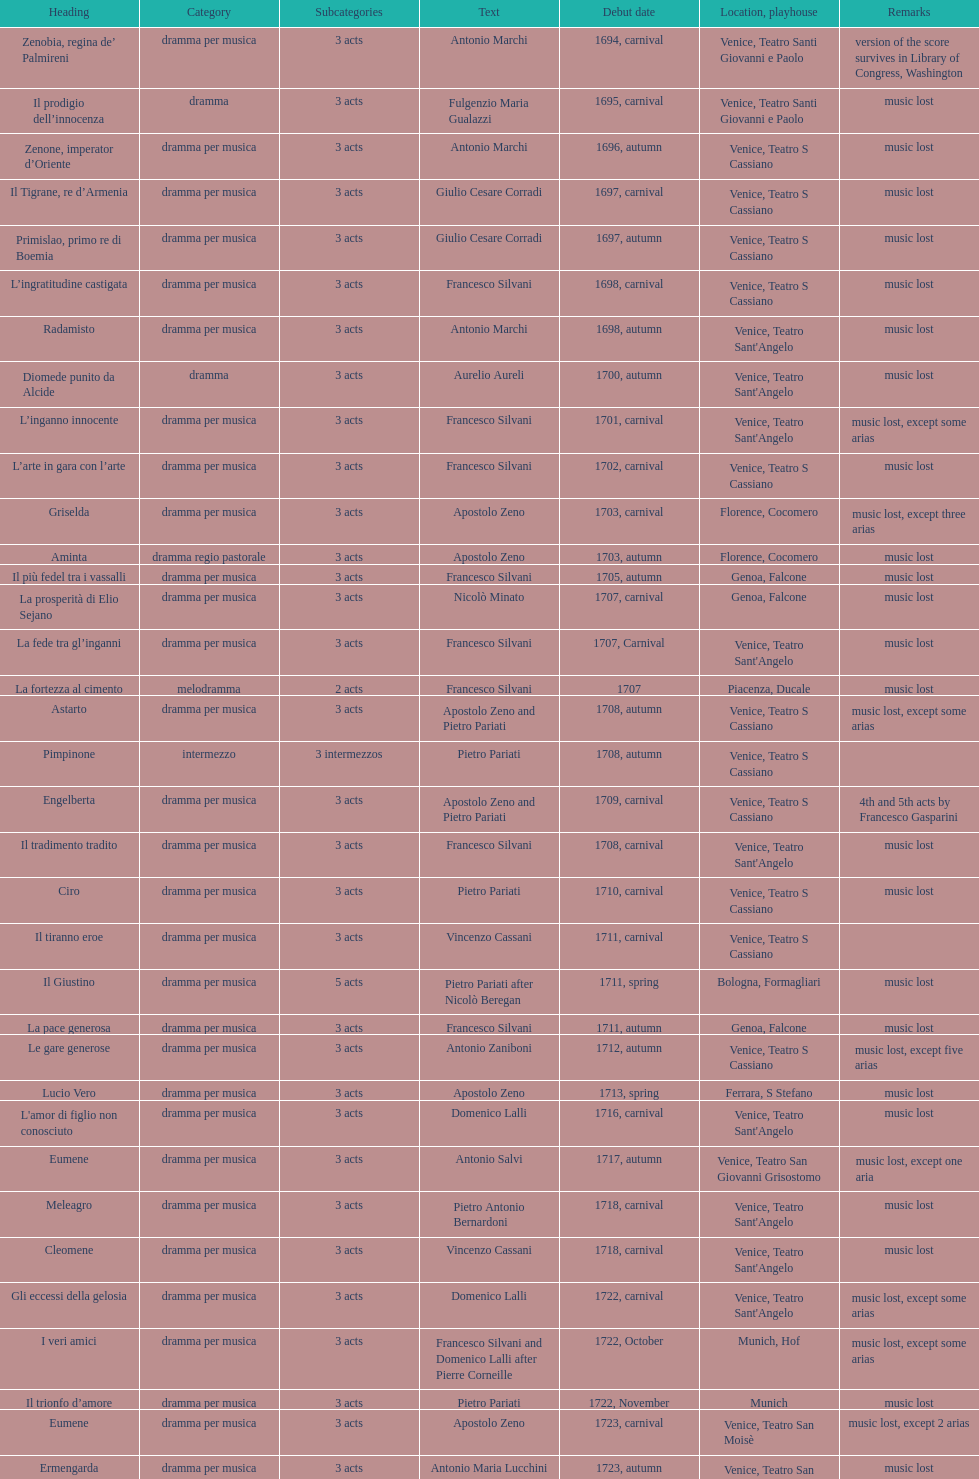Which was released earlier, artamene or merope? Merope. 